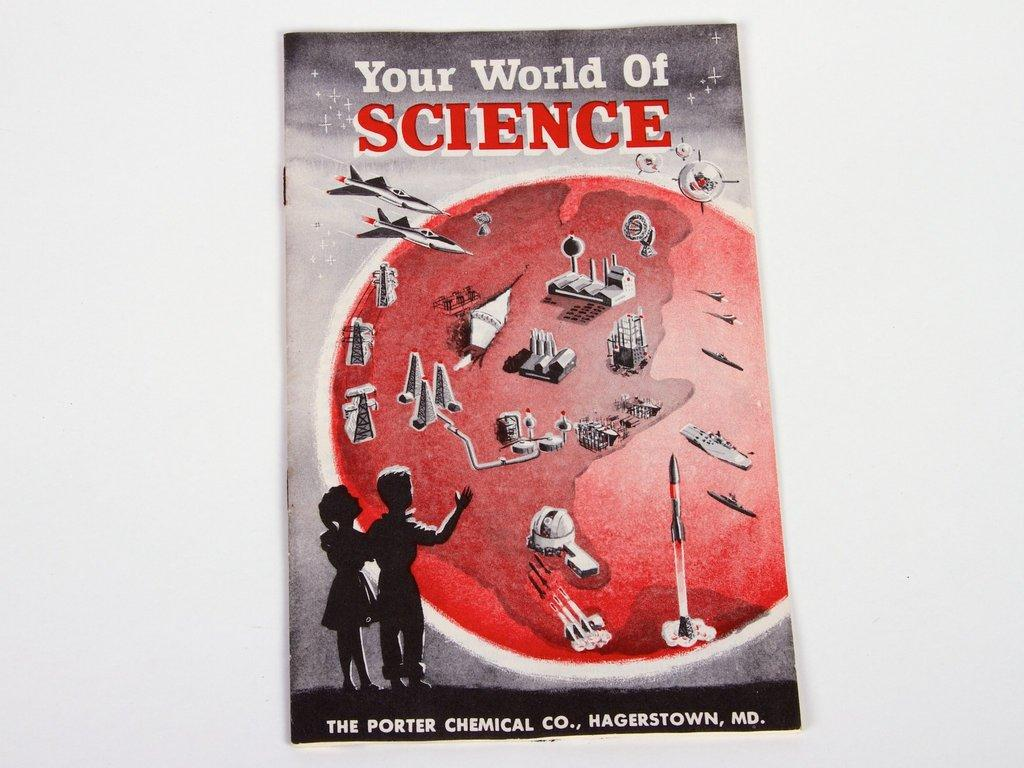Provide a one-sentence caption for the provided image. A book with two children titled Your World of Science. 